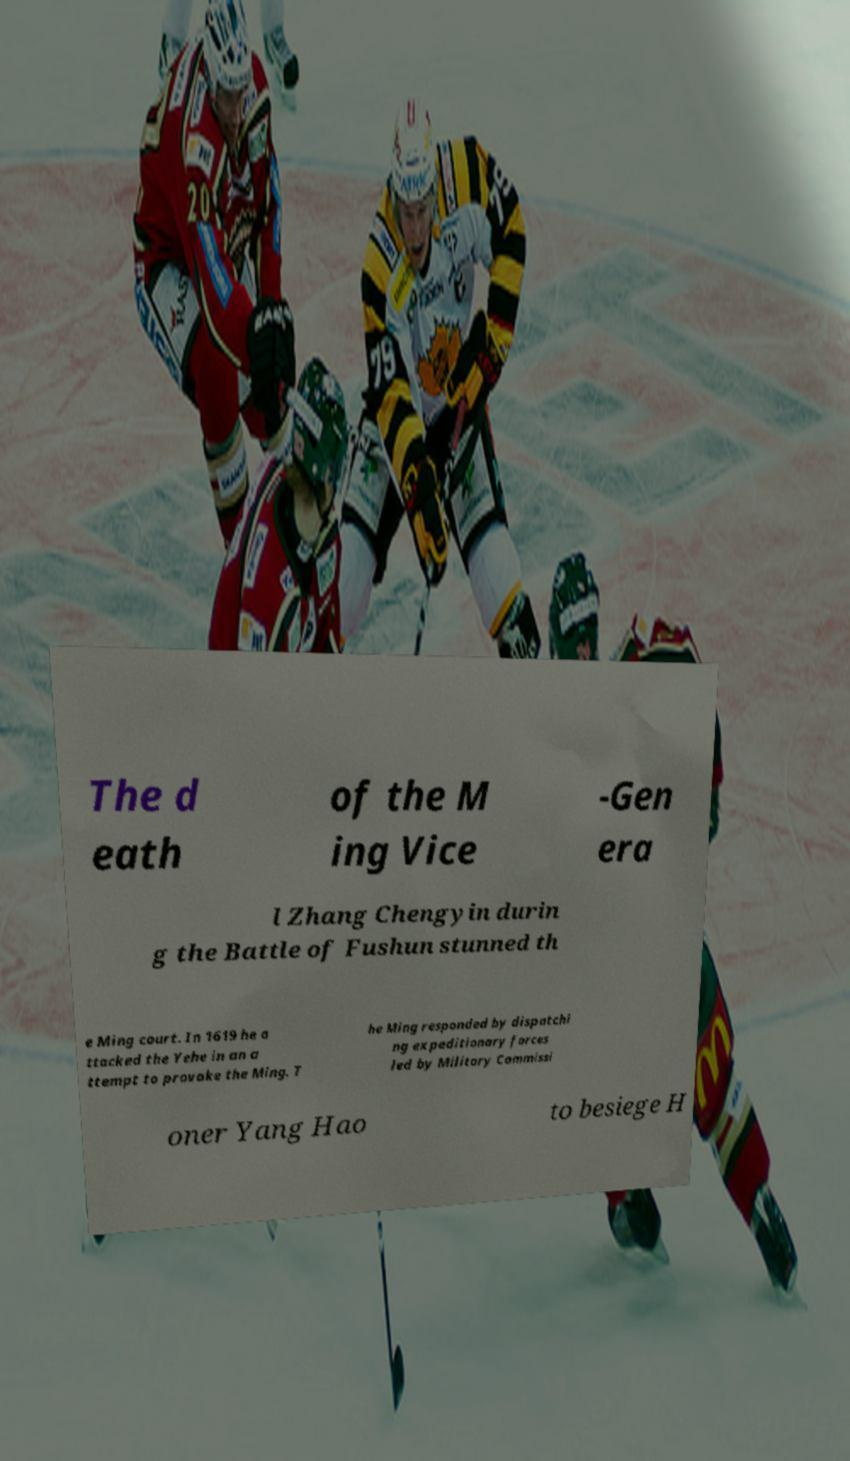What messages or text are displayed in this image? I need them in a readable, typed format. The d eath of the M ing Vice -Gen era l Zhang Chengyin durin g the Battle of Fushun stunned th e Ming court. In 1619 he a ttacked the Yehe in an a ttempt to provoke the Ming. T he Ming responded by dispatchi ng expeditionary forces led by Military Commissi oner Yang Hao to besiege H 